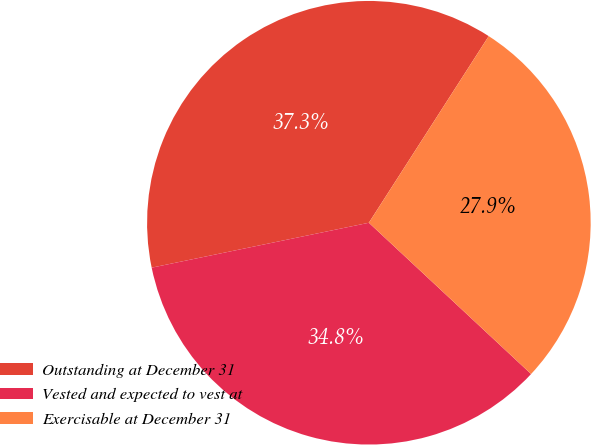Convert chart to OTSL. <chart><loc_0><loc_0><loc_500><loc_500><pie_chart><fcel>Outstanding at December 31<fcel>Vested and expected to vest at<fcel>Exercisable at December 31<nl><fcel>37.33%<fcel>34.81%<fcel>27.86%<nl></chart> 